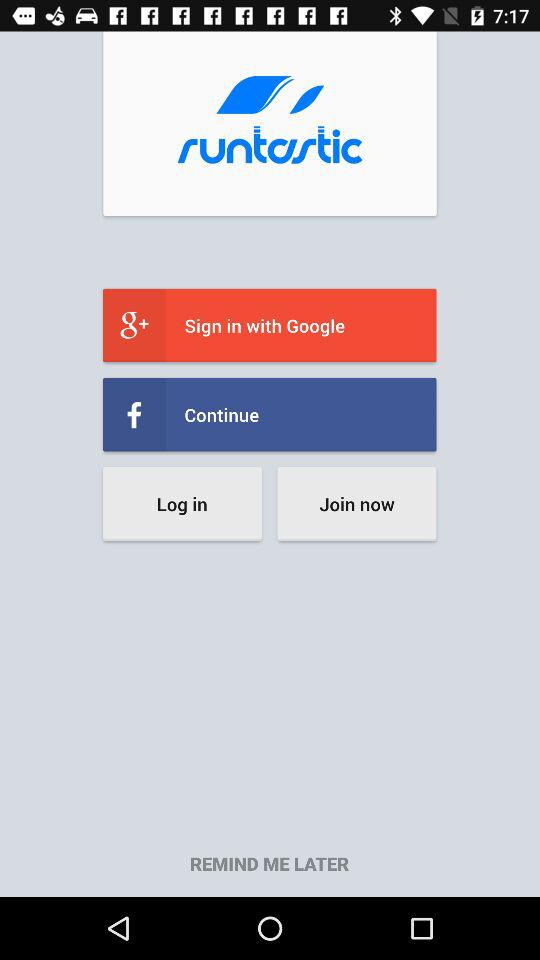Which options are given for the sign-in? The given options are "Google+" and "Facebook". 